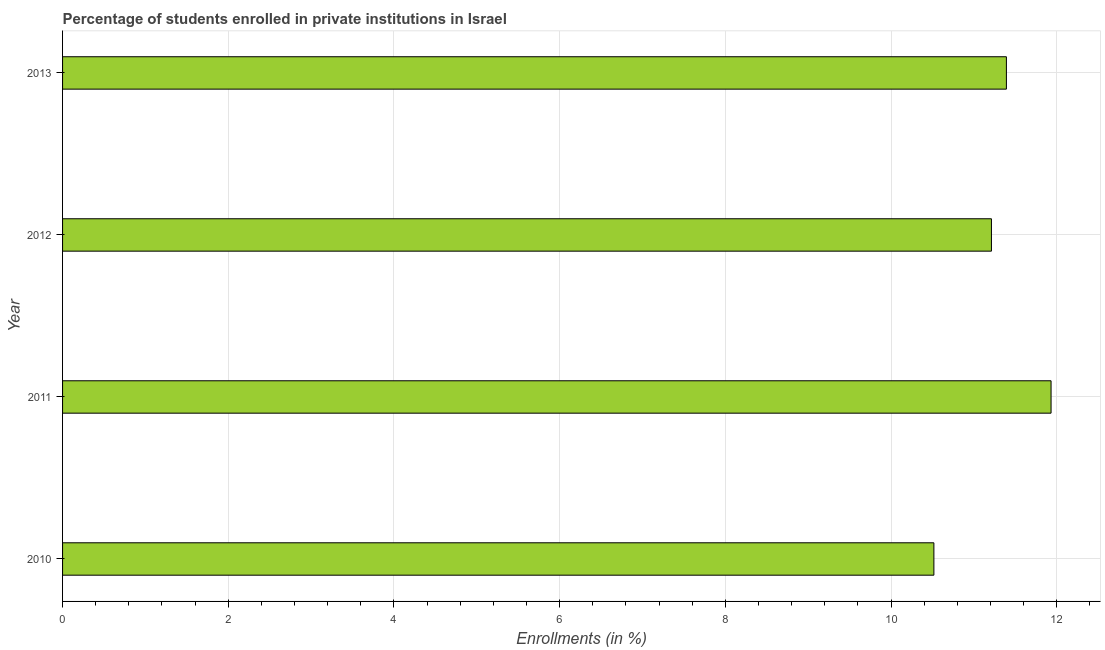Does the graph contain any zero values?
Provide a short and direct response. No. What is the title of the graph?
Your answer should be very brief. Percentage of students enrolled in private institutions in Israel. What is the label or title of the X-axis?
Your answer should be compact. Enrollments (in %). What is the enrollments in private institutions in 2013?
Offer a terse response. 11.39. Across all years, what is the maximum enrollments in private institutions?
Offer a very short reply. 11.93. Across all years, what is the minimum enrollments in private institutions?
Your response must be concise. 10.52. In which year was the enrollments in private institutions maximum?
Offer a terse response. 2011. What is the sum of the enrollments in private institutions?
Offer a very short reply. 45.05. What is the difference between the enrollments in private institutions in 2011 and 2013?
Give a very brief answer. 0.54. What is the average enrollments in private institutions per year?
Make the answer very short. 11.26. What is the median enrollments in private institutions?
Give a very brief answer. 11.3. What is the ratio of the enrollments in private institutions in 2010 to that in 2012?
Provide a short and direct response. 0.94. Is the enrollments in private institutions in 2011 less than that in 2012?
Your answer should be very brief. No. What is the difference between the highest and the second highest enrollments in private institutions?
Offer a very short reply. 0.54. What is the difference between the highest and the lowest enrollments in private institutions?
Offer a terse response. 1.41. In how many years, is the enrollments in private institutions greater than the average enrollments in private institutions taken over all years?
Ensure brevity in your answer.  2. How many bars are there?
Give a very brief answer. 4. What is the difference between two consecutive major ticks on the X-axis?
Your answer should be compact. 2. What is the Enrollments (in %) of 2010?
Provide a succinct answer. 10.52. What is the Enrollments (in %) of 2011?
Your answer should be compact. 11.93. What is the Enrollments (in %) of 2012?
Give a very brief answer. 11.21. What is the Enrollments (in %) in 2013?
Offer a very short reply. 11.39. What is the difference between the Enrollments (in %) in 2010 and 2011?
Keep it short and to the point. -1.41. What is the difference between the Enrollments (in %) in 2010 and 2012?
Keep it short and to the point. -0.69. What is the difference between the Enrollments (in %) in 2010 and 2013?
Provide a short and direct response. -0.88. What is the difference between the Enrollments (in %) in 2011 and 2012?
Keep it short and to the point. 0.72. What is the difference between the Enrollments (in %) in 2011 and 2013?
Ensure brevity in your answer.  0.54. What is the difference between the Enrollments (in %) in 2012 and 2013?
Your answer should be compact. -0.18. What is the ratio of the Enrollments (in %) in 2010 to that in 2011?
Give a very brief answer. 0.88. What is the ratio of the Enrollments (in %) in 2010 to that in 2012?
Your answer should be compact. 0.94. What is the ratio of the Enrollments (in %) in 2010 to that in 2013?
Offer a very short reply. 0.92. What is the ratio of the Enrollments (in %) in 2011 to that in 2012?
Ensure brevity in your answer.  1.06. What is the ratio of the Enrollments (in %) in 2011 to that in 2013?
Offer a terse response. 1.05. 